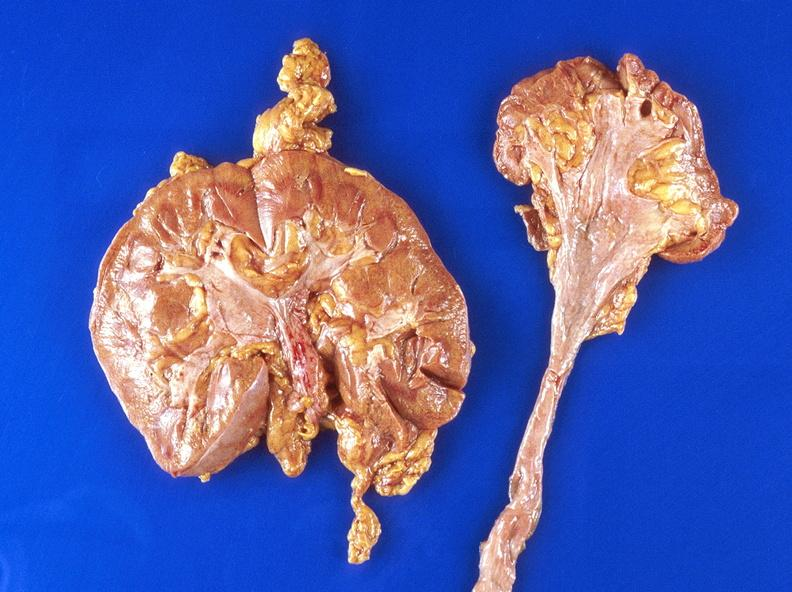does this image show hydronephrosis?
Answer the question using a single word or phrase. Yes 